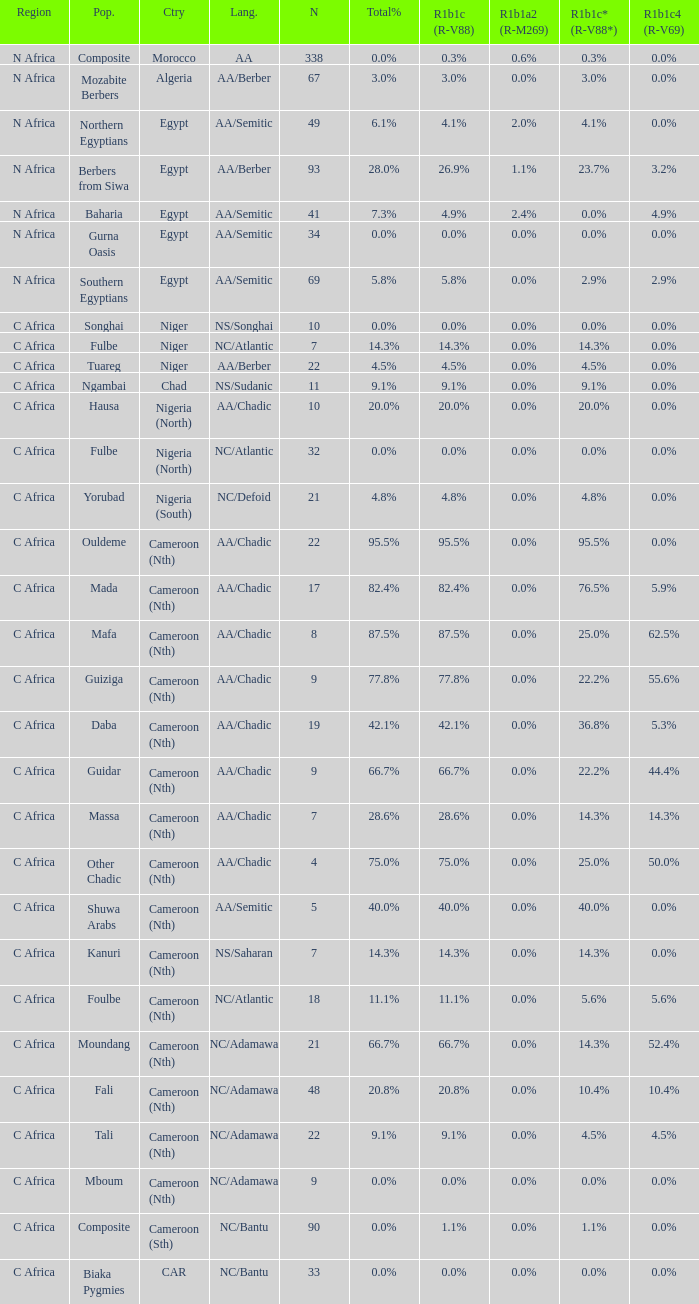What percentage is listed in column r1b1a2 (r-m269) for the 77.8% r1b1c (r-v88)? 0.0%. 